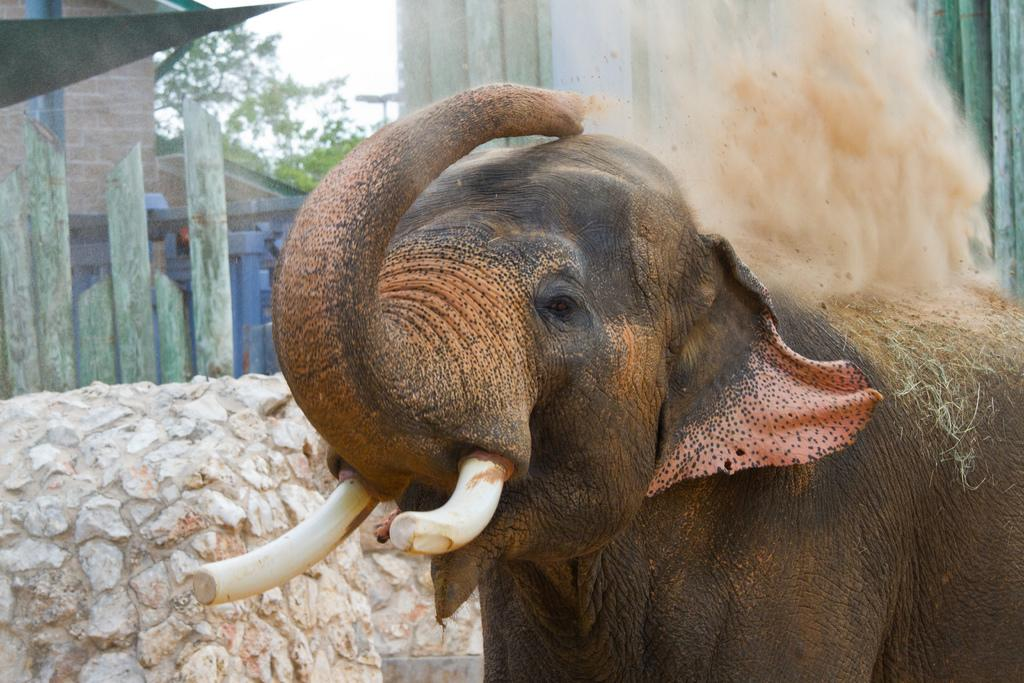What animal is the main subject of the image? There is an elephant in the image. What is located beside the elephant? There is a wall with bricks beside the elephant. What can be seen in the distance in the image? There are buildings and trees in the background of the image. What part of the natural environment is visible in the image? The sky is visible in the background of the image. How many frogs are sitting on the elephant's back in the image? There are no frogs present in the image; it features an elephant and a wall with bricks. What type of map is visible on the wall beside the elephant? There is no map visible on the wall beside the elephant; it is a wall with bricks. 